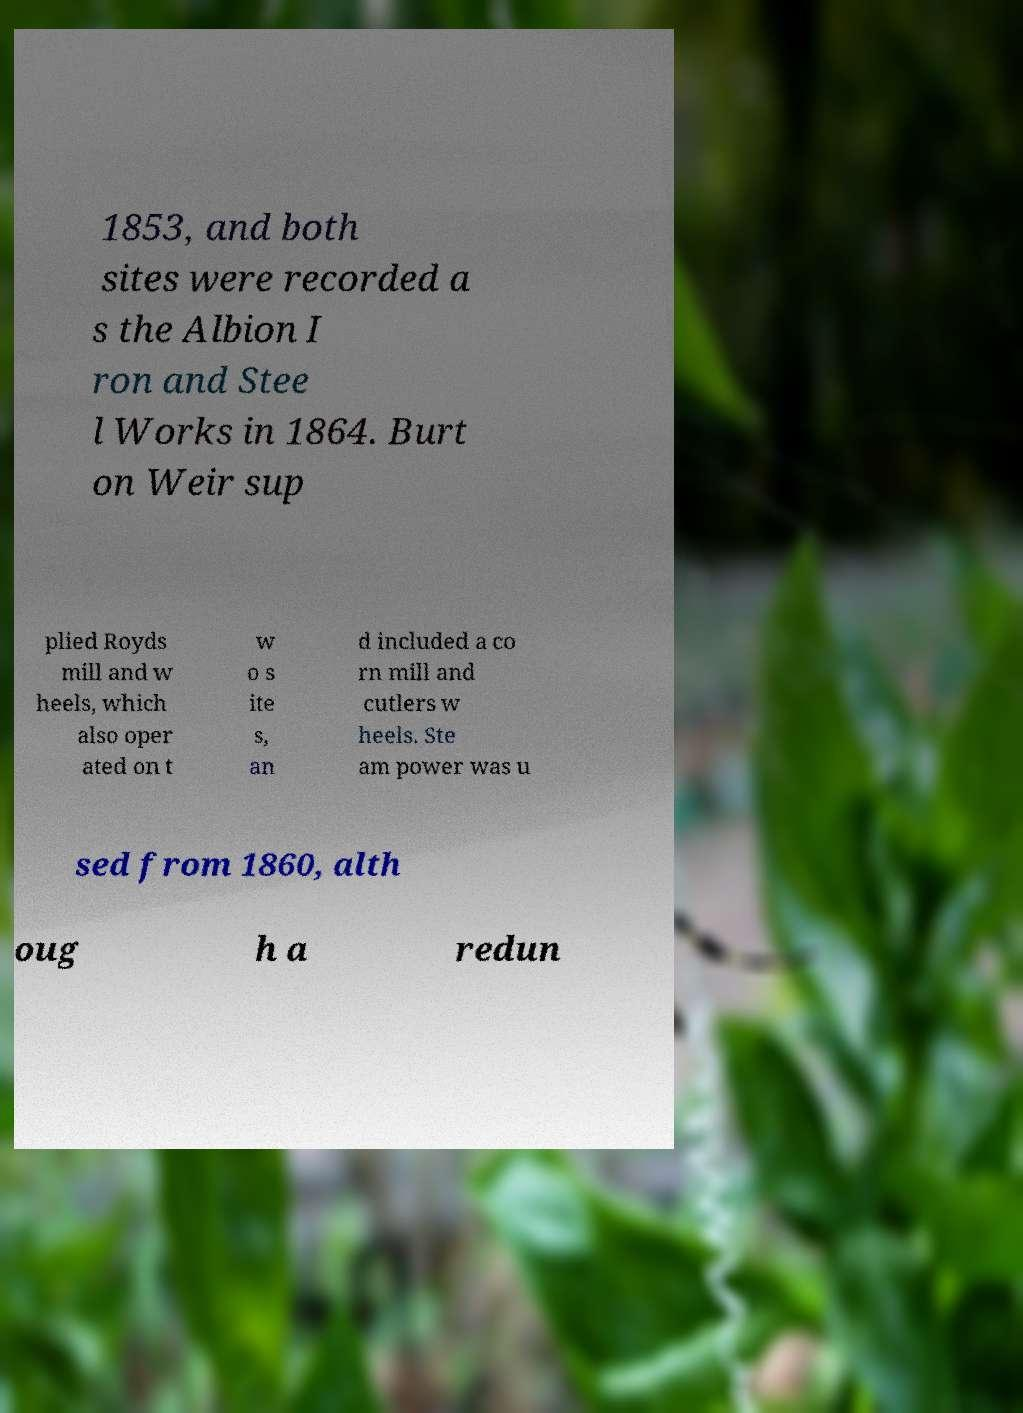What messages or text are displayed in this image? I need them in a readable, typed format. 1853, and both sites were recorded a s the Albion I ron and Stee l Works in 1864. Burt on Weir sup plied Royds mill and w heels, which also oper ated on t w o s ite s, an d included a co rn mill and cutlers w heels. Ste am power was u sed from 1860, alth oug h a redun 